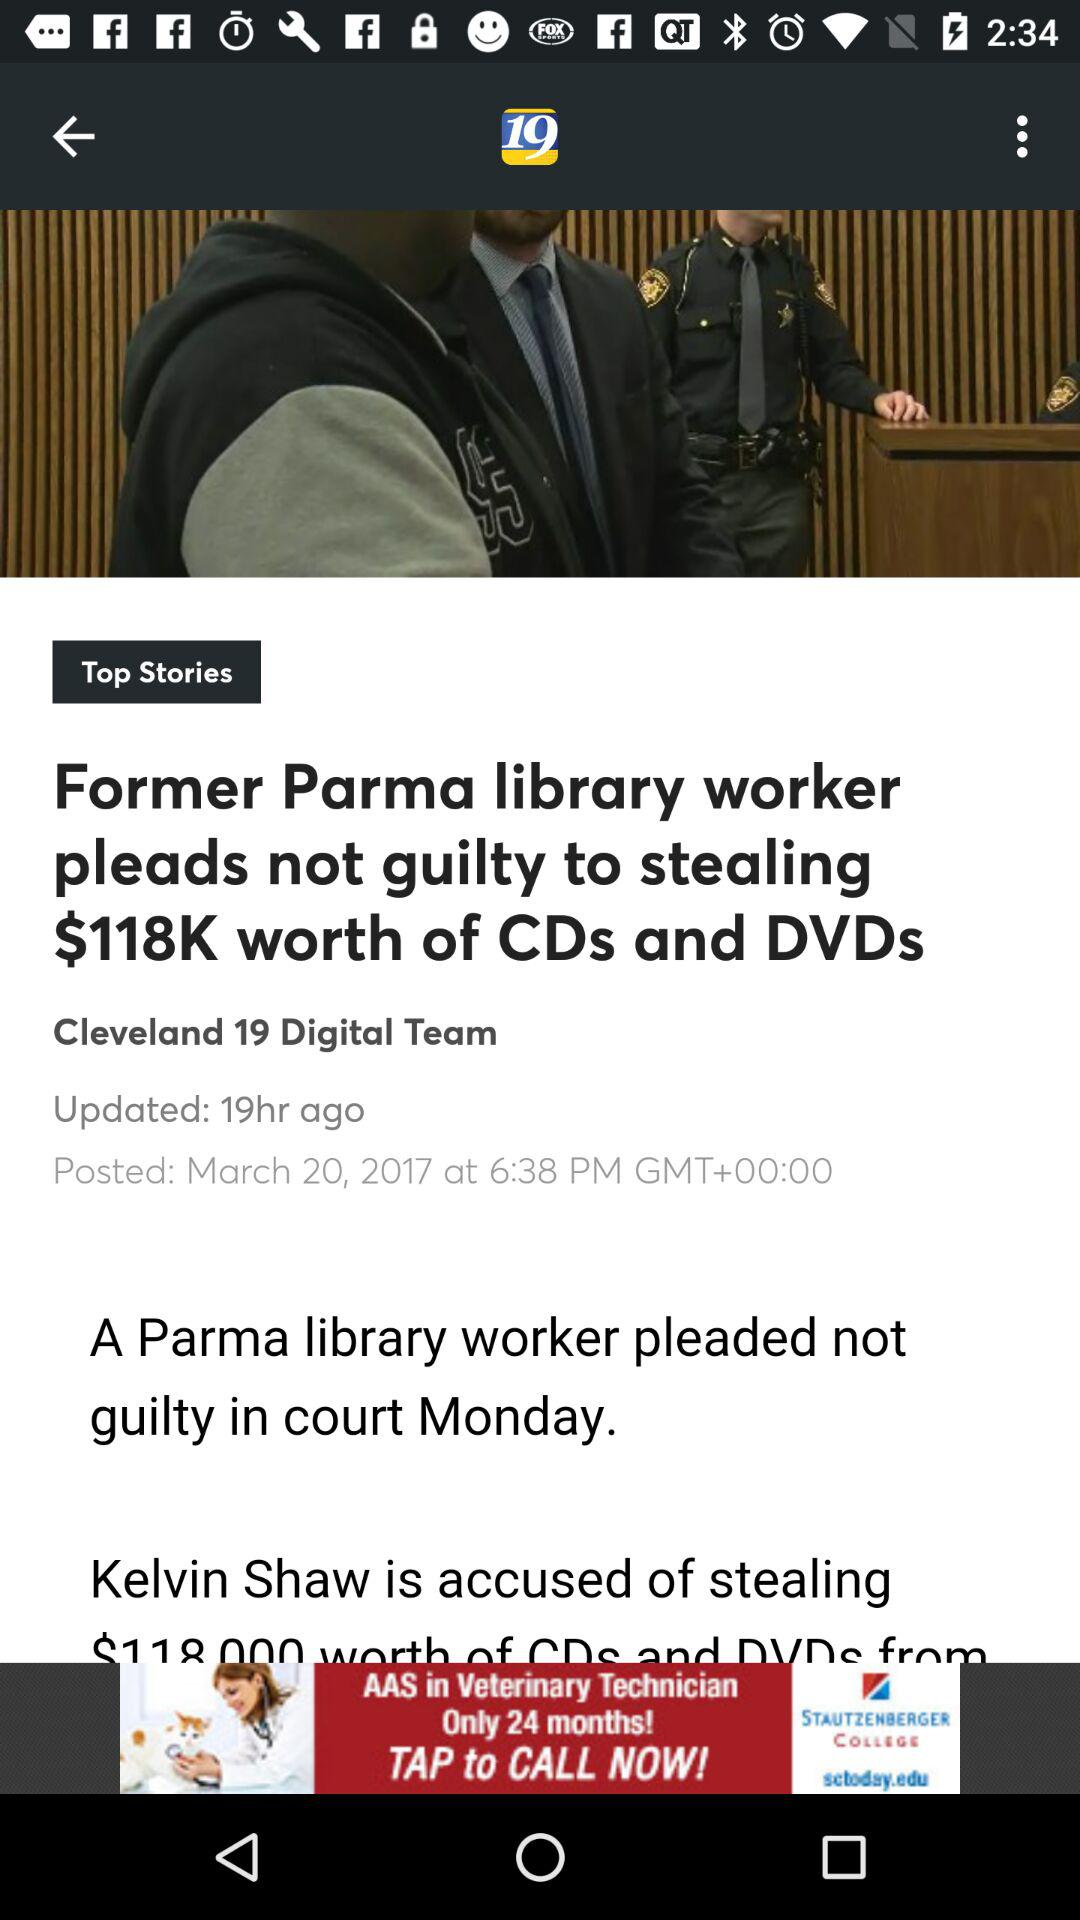When was the news about the former Parma library worker updated? It was last updated 19 hours ago. 